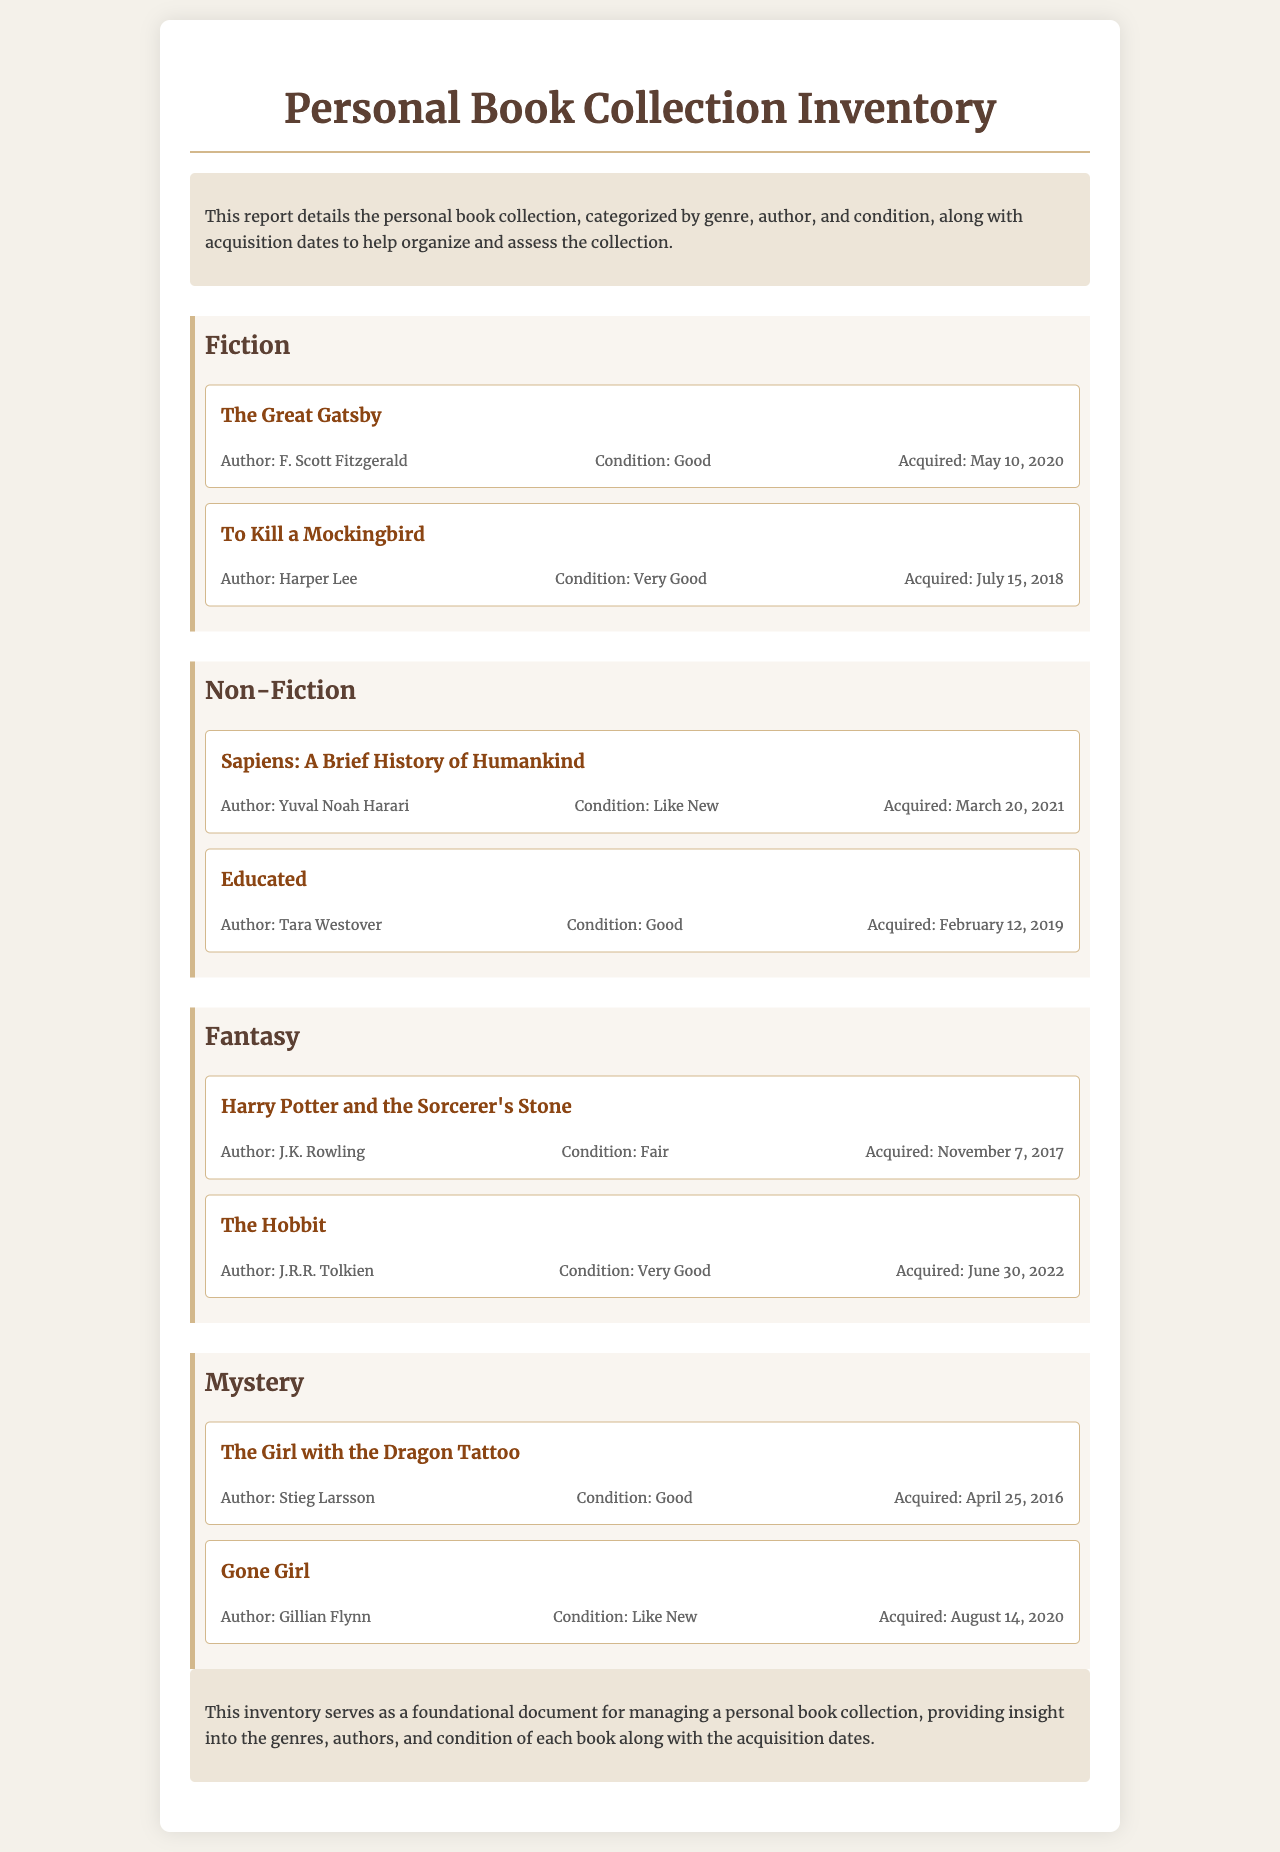What is the title of the first fiction book listed? The title of the first fiction book is mentioned in the genre section under Fiction, which is "The Great Gatsby."
Answer: The Great Gatsby Who is the author of "Educated"? The author of "Educated" is found in the Non-Fiction genre section, and it is Tara Westover.
Answer: Tara Westover What condition is "Harry Potter and the Sorcerer's Stone" in? The condition of "Harry Potter and the Sorcerer's Stone" is specified in the Fantasy genre section, which is Fair.
Answer: Fair When was "Gone Girl" acquired? The acquisition date for "Gone Girl" is stated in the Mystery genre section, which is August 14, 2020.
Answer: August 14, 2020 How many genres are listed in the inventory? The number of genres can be counted in the document, and they include Fiction, Non-Fiction, Fantasy, and Mystery, totaling four genres.
Answer: Four Which book has the condition of "Like New"? The book that is listed as "Like New" condition is identified in the document under the Mystery genre as "Gone Girl."
Answer: Gone Girl Which author has two books in the collection? The author that can be identified in the document as having two books is J.K. Rowling, who wrote "Harry Potter and the Sorcerer's Stone."
Answer: J.K. Rowling 